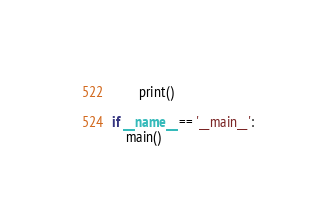<code> <loc_0><loc_0><loc_500><loc_500><_Python_>		print()

if __name__ == '__main__':
	main()
</code> 